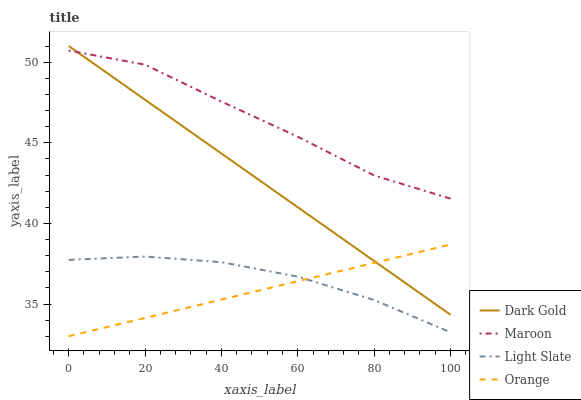Does Maroon have the minimum area under the curve?
Answer yes or no. No. Does Orange have the maximum area under the curve?
Answer yes or no. No. Is Orange the smoothest?
Answer yes or no. No. Is Orange the roughest?
Answer yes or no. No. Does Maroon have the lowest value?
Answer yes or no. No. Does Orange have the highest value?
Answer yes or no. No. Is Orange less than Maroon?
Answer yes or no. Yes. Is Dark Gold greater than Light Slate?
Answer yes or no. Yes. Does Orange intersect Maroon?
Answer yes or no. No. 